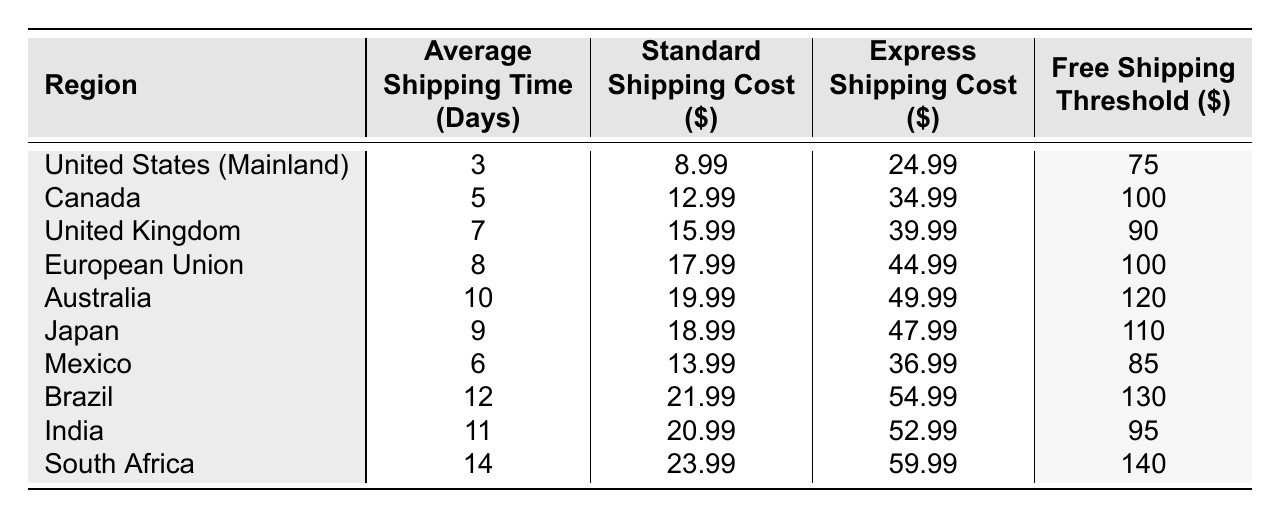What is the standard shipping cost for orders to Canada? In the table, I find that the standard shipping cost for Canada is listed under the corresponding row. It shows a value of 12.99.
Answer: 12.99 Which region has the longest average shipping time? By scanning the average shipping time column, South Africa has the highest value, which is 14 days.
Answer: South Africa Is the express shipping cost for Japan more than 45 dollars? Looking at the express shipping cost column for Japan, the value is 47.99, which is indeed greater than 45.
Answer: Yes What is the difference in standard shipping costs between the United Kingdom and Brazil? The standard shipping cost for the United Kingdom is 15.99, and for Brazil, it is 21.99. The difference is calculated by subtracting the UK cost from the Brazil cost: 21.99 - 15.99 = 6.00.
Answer: 6.00 What is the average express shipping cost of all regions listed in the table? To find the average, I will first sum all express shipping costs: 24.99 + 34.99 + 39.99 + 44.99 + 49.99 + 47.99 + 36.99 + 54.99 + 52.99 + 59.99 =  499.9. There are 10 regions, so the average is 499.9 / 10 = 49.99.
Answer: 49.99 Which region has the lowest free shipping threshold? By checking the free shipping threshold column, I see that the United States (Mainland) has the lowest value at 75 dollars.
Answer: United States (Mainland) Is the average shipping time to Australia less than that of Canada? Checking the average shipping times, Australia has 10 days and Canada has 5 days. Since 10 is not less than 5, the answer is no.
Answer: No What is the total threshold for free shipping when considering all regions together? To find the total, I will sum all the free shipping thresholds: 75 + 100 + 90 + 100 + 120 + 110 + 85 + 130 + 95 + 140 = 1,100.
Answer: 1100 Which region requires a free shipping threshold of at least 130 dollars? Looking across the free shipping threshold column, Brazil and South Africa are the regions that require at least 130 dollars.
Answer: Brazil, South Africa How much more does express shipping cost to the United Kingdom compared to Mexico? The express shipping cost for the United Kingdom is 39.99 and for Mexico it is 36.99. The difference is 39.99 - 36.99 = 3.00.
Answer: 3.00 Is there any region where the average shipping time is exactly 10 days? According to the table, Australia has an average shipping time of 10 days, which confirms that there is such a region.
Answer: Yes 